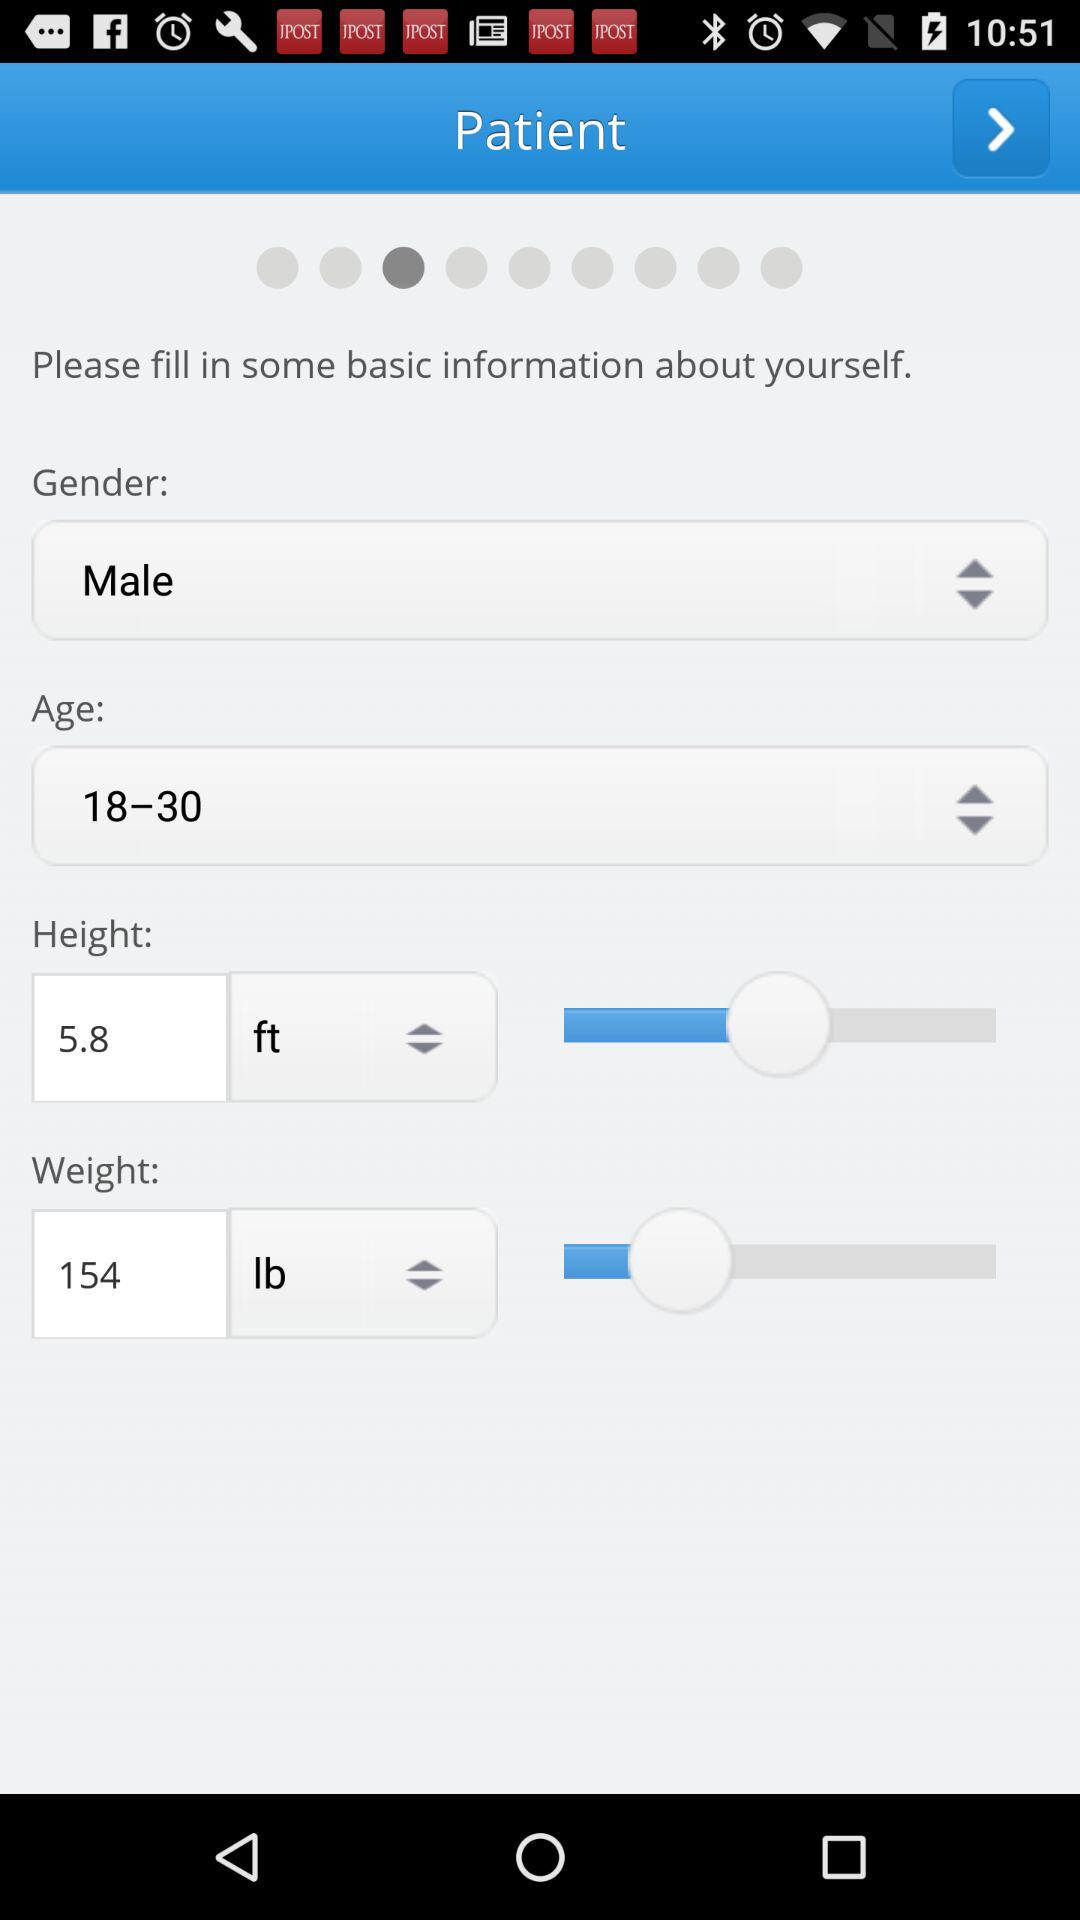What's the age range? The age range is 18 to 30. 